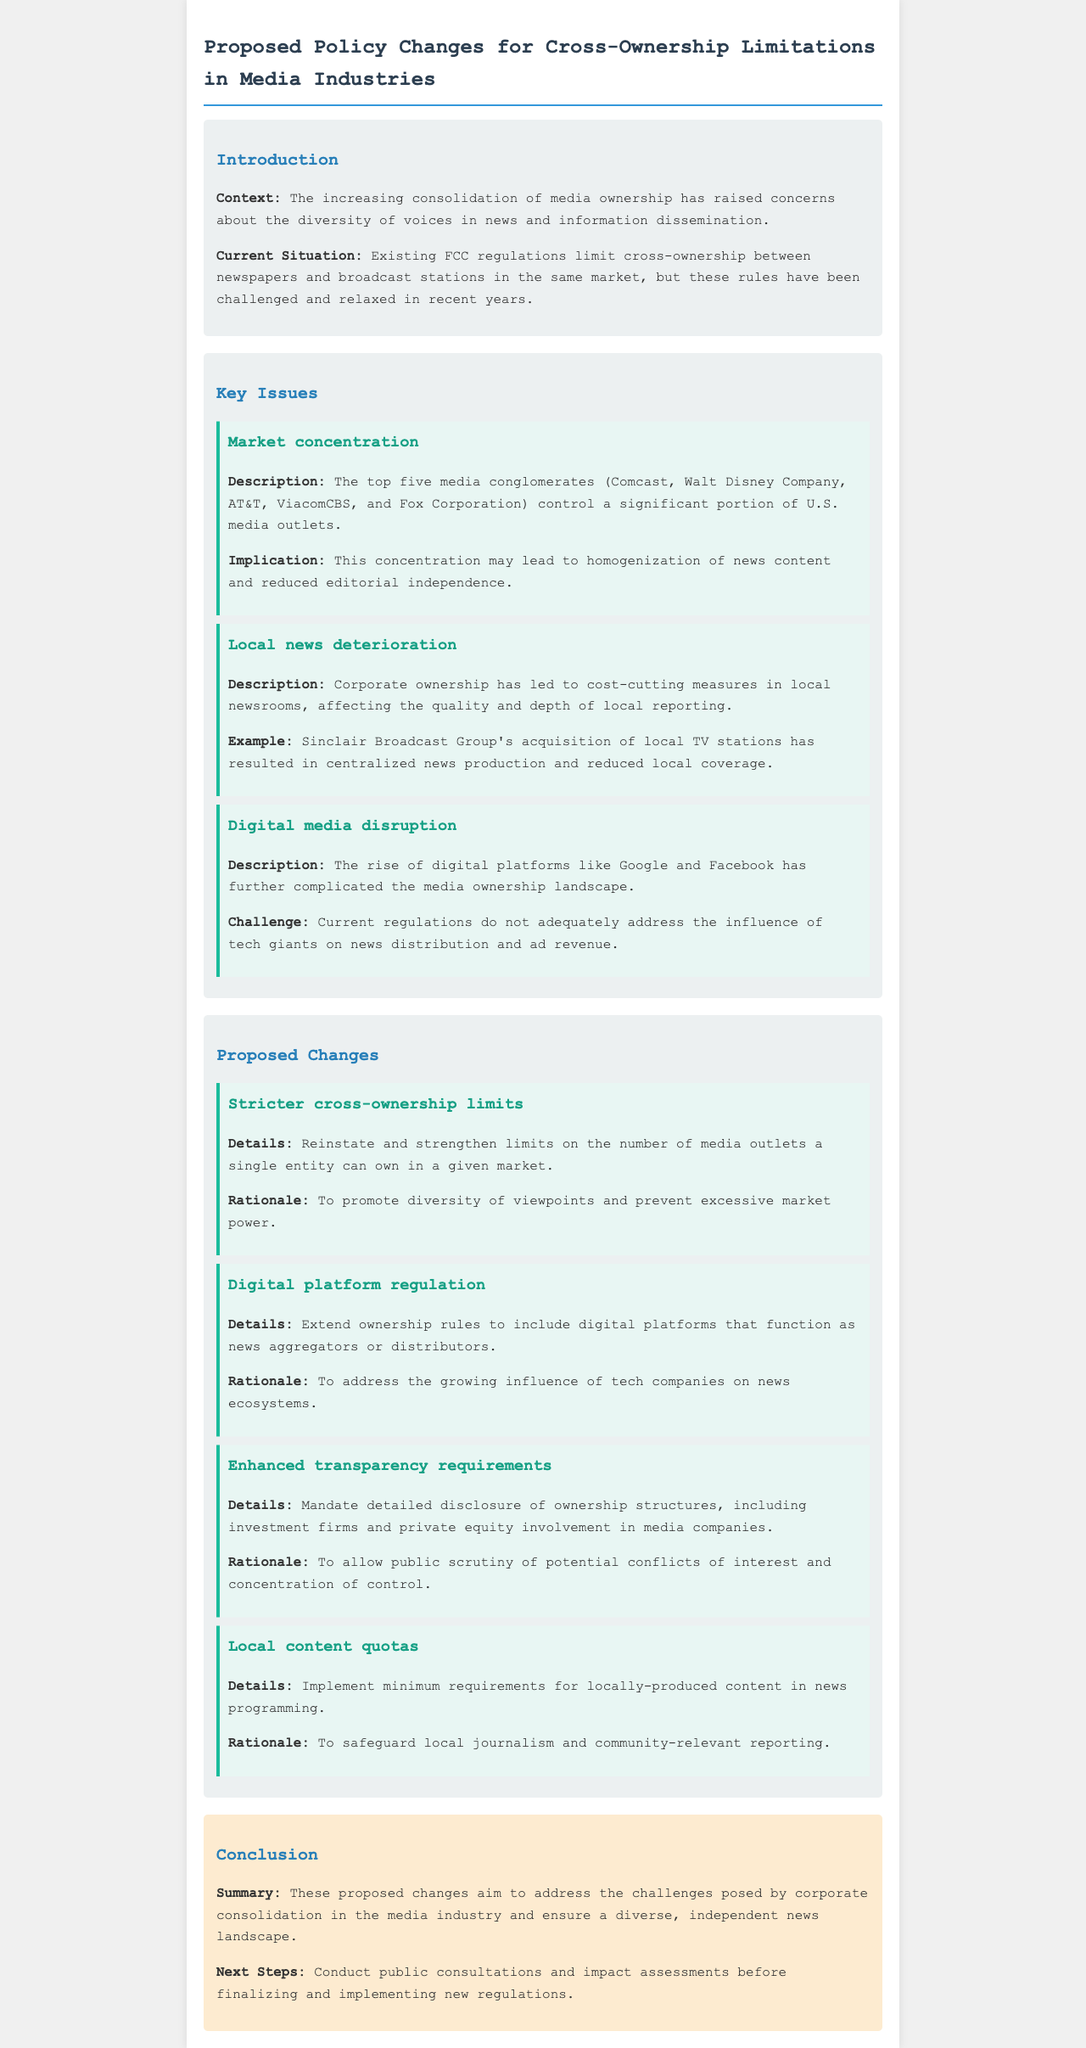What is the main context of the document? The document discusses the increasing consolidation of media ownership and its impact on the diversity of voices in news and information dissemination.
Answer: Consolidation of media ownership Who are the top five media conglomerates mentioned? The top five media conglomerates controlling a significant portion of U.S. media outlets are listed in the document.
Answer: Comcast, Walt Disney Company, AT&T, ViacomCBS, Fox Corporation What is one implication of market concentration? The document states that a consequence of market concentration is reduced editorial independence.
Answer: Reduced editorial independence What does the proposed policy change regarding digital platforms entail? The document suggests extending ownership rules to cover digital platforms functioning as news aggregators or distributors.
Answer: Extend ownership rules What is a proposed change related to local content? The policy includes implementing minimum requirements for locally-produced content in news programming.
Answer: Local content quotas What is the rationale for stricter cross-ownership limits? The document provides a rationale for stricter cross-ownership limits as a means to promote diversity of viewpoints.
Answer: Promote diversity of viewpoints What is one challenge posed by digital media disruption? The document outlines that current regulations do not adequately address the influence of tech giants on news distribution and ad revenue.
Answer: Influence of tech giants What should happen after the proposed changes are stated? The next steps mentioned in the document include conducting public consultations and impact assessments.
Answer: Conduct public consultations 